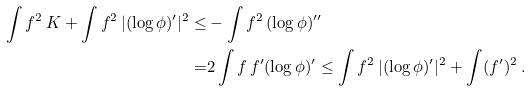Convert formula to latex. <formula><loc_0><loc_0><loc_500><loc_500>\int f ^ { 2 } \, K + \int f ^ { 2 } \, | ( \log \phi ) ^ { \prime } | ^ { 2 } \leq & - \int f ^ { 2 } \, ( \log \phi ) ^ { \prime \prime } \\ = & 2 \int f \, f ^ { \prime } ( \log \phi ) ^ { \prime } \leq \int f ^ { 2 } \, | ( \log \phi ) ^ { \prime } | ^ { 2 } + \int ( f ^ { \prime } ) ^ { 2 } \, .</formula> 